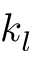Convert formula to latex. <formula><loc_0><loc_0><loc_500><loc_500>k _ { l }</formula> 